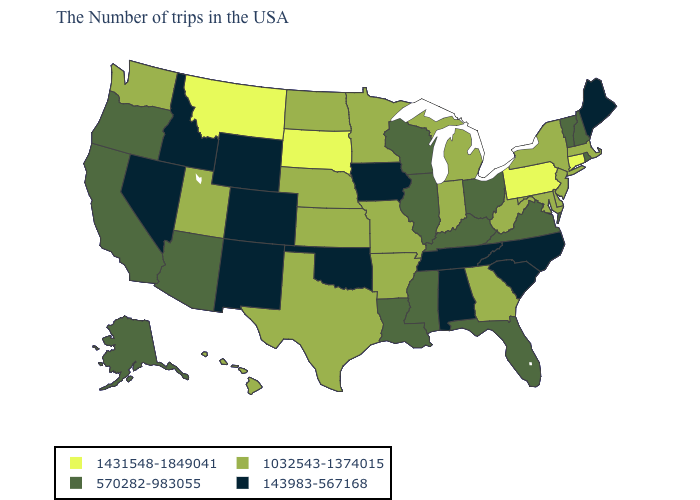What is the value of New Mexico?
Short answer required. 143983-567168. What is the value of Iowa?
Write a very short answer. 143983-567168. What is the value of New Hampshire?
Keep it brief. 570282-983055. What is the highest value in the Northeast ?
Keep it brief. 1431548-1849041. Which states have the highest value in the USA?
Keep it brief. Connecticut, Pennsylvania, South Dakota, Montana. Name the states that have a value in the range 143983-567168?
Answer briefly. Maine, North Carolina, South Carolina, Alabama, Tennessee, Iowa, Oklahoma, Wyoming, Colorado, New Mexico, Idaho, Nevada. What is the highest value in the USA?
Write a very short answer. 1431548-1849041. Which states have the highest value in the USA?
Concise answer only. Connecticut, Pennsylvania, South Dakota, Montana. Name the states that have a value in the range 143983-567168?
Give a very brief answer. Maine, North Carolina, South Carolina, Alabama, Tennessee, Iowa, Oklahoma, Wyoming, Colorado, New Mexico, Idaho, Nevada. Name the states that have a value in the range 143983-567168?
Concise answer only. Maine, North Carolina, South Carolina, Alabama, Tennessee, Iowa, Oklahoma, Wyoming, Colorado, New Mexico, Idaho, Nevada. Does Montana have the same value as Colorado?
Answer briefly. No. Which states have the lowest value in the USA?
Give a very brief answer. Maine, North Carolina, South Carolina, Alabama, Tennessee, Iowa, Oklahoma, Wyoming, Colorado, New Mexico, Idaho, Nevada. What is the highest value in states that border Iowa?
Short answer required. 1431548-1849041. What is the highest value in the West ?
Answer briefly. 1431548-1849041. What is the value of Wisconsin?
Short answer required. 570282-983055. 